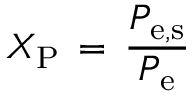Convert formula to latex. <formula><loc_0><loc_0><loc_500><loc_500>X _ { P } \, = \, \frac { P _ { e , s } } { P _ { e } }</formula> 